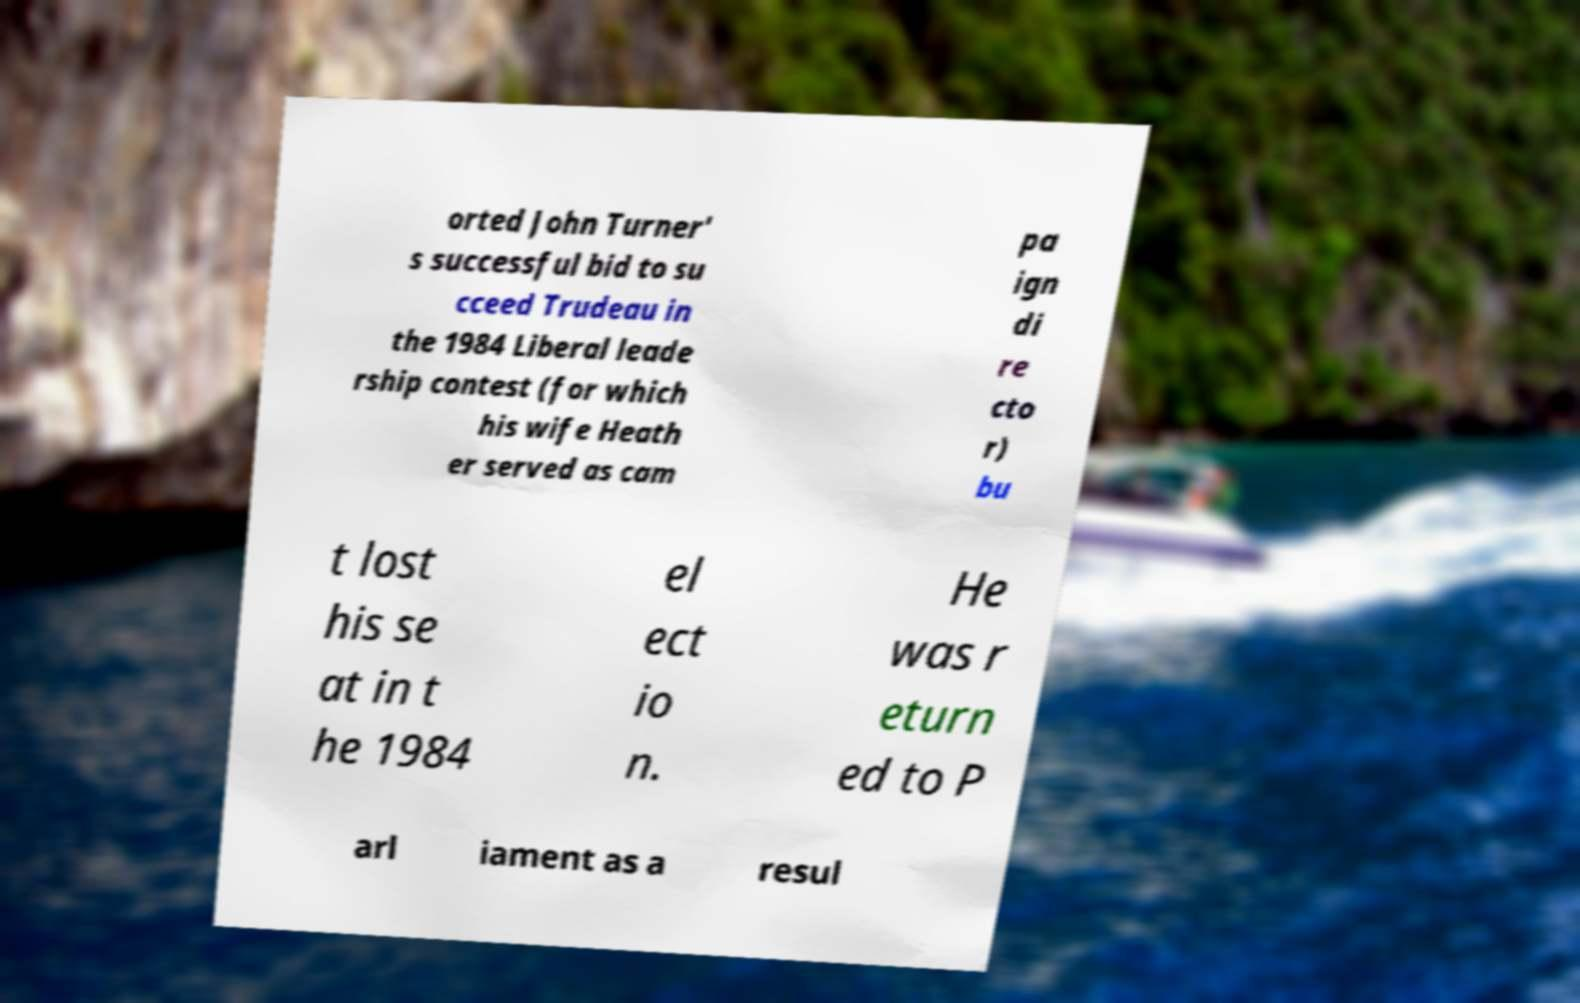Could you extract and type out the text from this image? orted John Turner' s successful bid to su cceed Trudeau in the 1984 Liberal leade rship contest (for which his wife Heath er served as cam pa ign di re cto r) bu t lost his se at in t he 1984 el ect io n. He was r eturn ed to P arl iament as a resul 